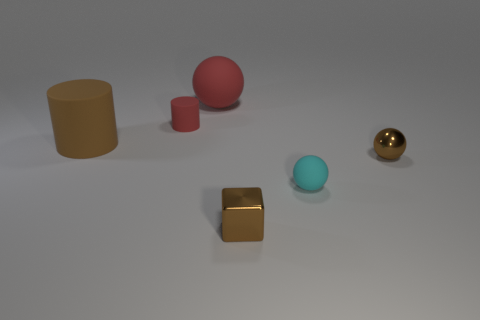What is the size of the matte object that is the same color as the large matte ball?
Keep it short and to the point. Small. Is the shape of the small brown thing right of the cyan rubber ball the same as  the large red object?
Make the answer very short. Yes. What number of matte objects are both in front of the large rubber sphere and left of the tiny shiny cube?
Offer a very short reply. 2. There is a tiny red rubber thing in front of the red sphere; what is its shape?
Keep it short and to the point. Cylinder. What number of red cylinders are made of the same material as the brown cube?
Offer a very short reply. 0. Is the shape of the big red thing the same as the rubber thing in front of the brown rubber thing?
Give a very brief answer. Yes. There is a brown object in front of the small brown thing behind the brown block; are there any small objects that are right of it?
Give a very brief answer. Yes. There is a rubber sphere that is in front of the small red rubber object; how big is it?
Your answer should be compact. Small. There is a brown sphere that is the same size as the cyan sphere; what material is it?
Offer a very short reply. Metal. Do the big red object and the cyan rubber object have the same shape?
Your answer should be compact. Yes. 